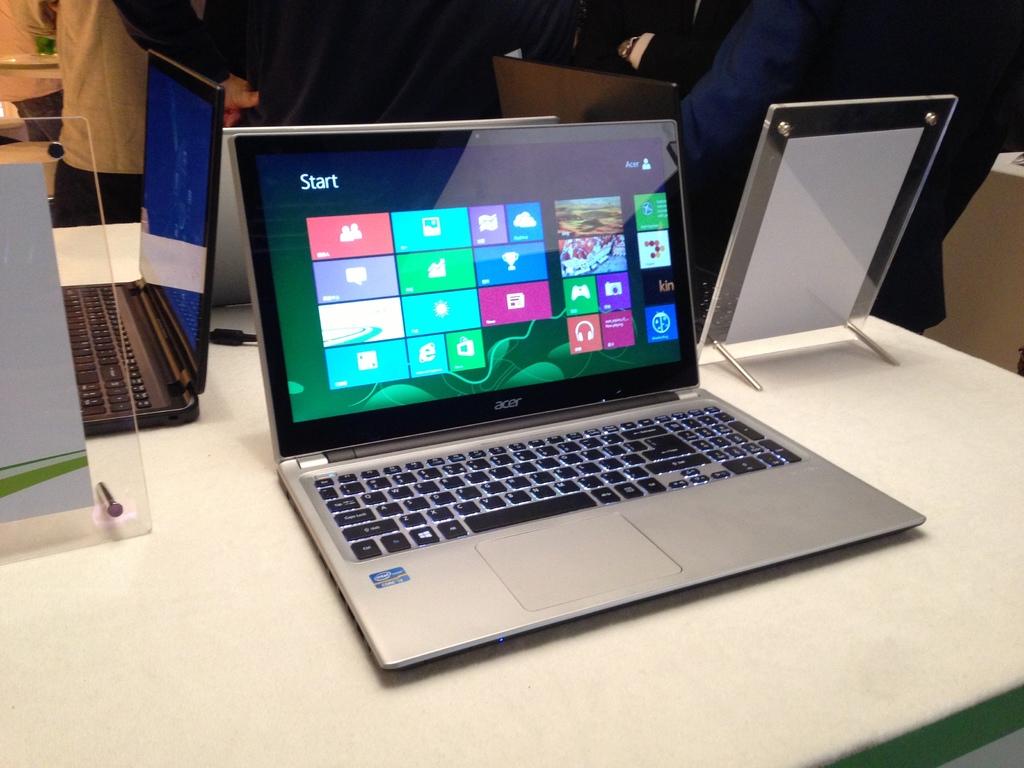Which laptop it?
Make the answer very short. Acer. 